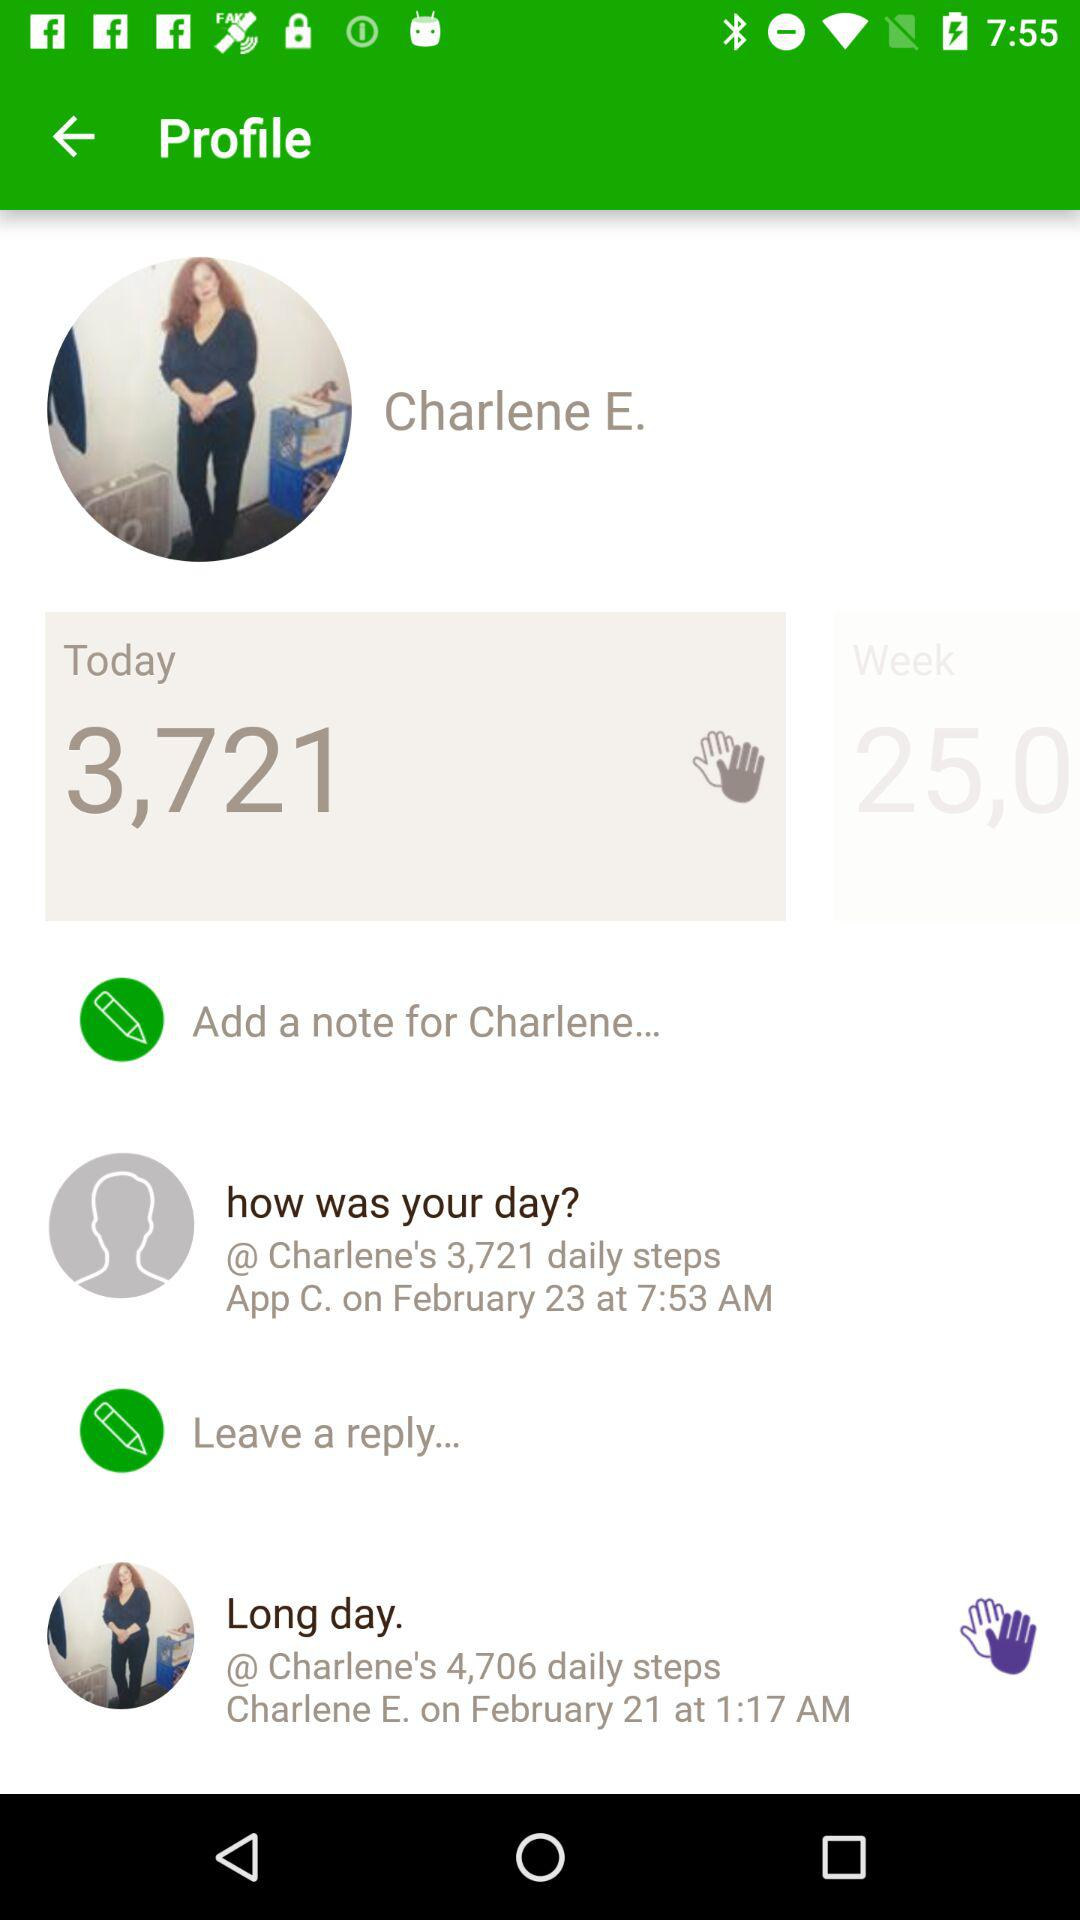What is the name of the user? The name of the user is "Charlene E.". 